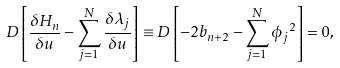Convert formula to latex. <formula><loc_0><loc_0><loc_500><loc_500>D \left [ \frac { \delta H _ { n } } { \delta u } - \sum _ { j = 1 } ^ { N } \frac { \delta \lambda _ { j } } { \delta u } \right ] \equiv D \left [ - 2 b _ { n + 2 } - \sum _ { j = 1 } ^ { N } { \phi _ { j } } ^ { 2 } \right ] = 0 ,</formula> 